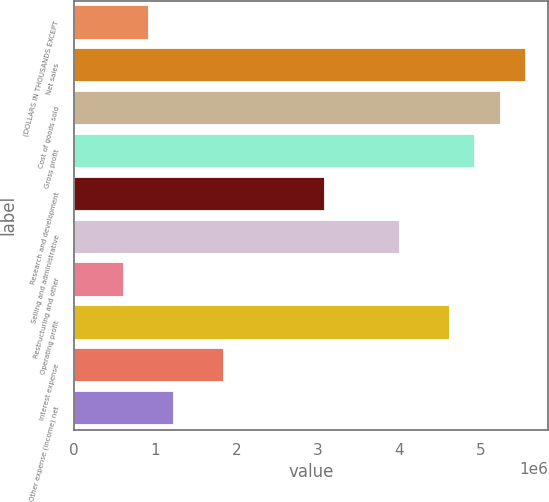<chart> <loc_0><loc_0><loc_500><loc_500><bar_chart><fcel>(DOLLARS IN THOUSANDS EXCEPT<fcel>Net sales<fcel>Cost of goods sold<fcel>Gross profit<fcel>Research and development<fcel>Selling and administrative<fcel>Restructuring and other<fcel>Operating profit<fcel>Interest expense<fcel>Other expense (income) net<nl><fcel>926563<fcel>5.55936e+06<fcel>5.2505e+06<fcel>4.94165e+06<fcel>3.08853e+06<fcel>4.01509e+06<fcel>617711<fcel>4.6328e+06<fcel>1.85312e+06<fcel>1.23542e+06<nl></chart> 